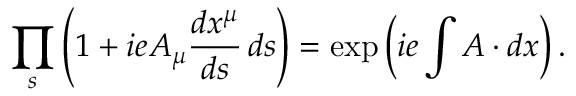<formula> <loc_0><loc_0><loc_500><loc_500>\prod _ { s } \left ( 1 + i e A _ { \mu } { \frac { d x ^ { \mu } } { d s } } \, d s \right ) = \exp \left ( i e \int A \cdot d x \right ) .</formula> 